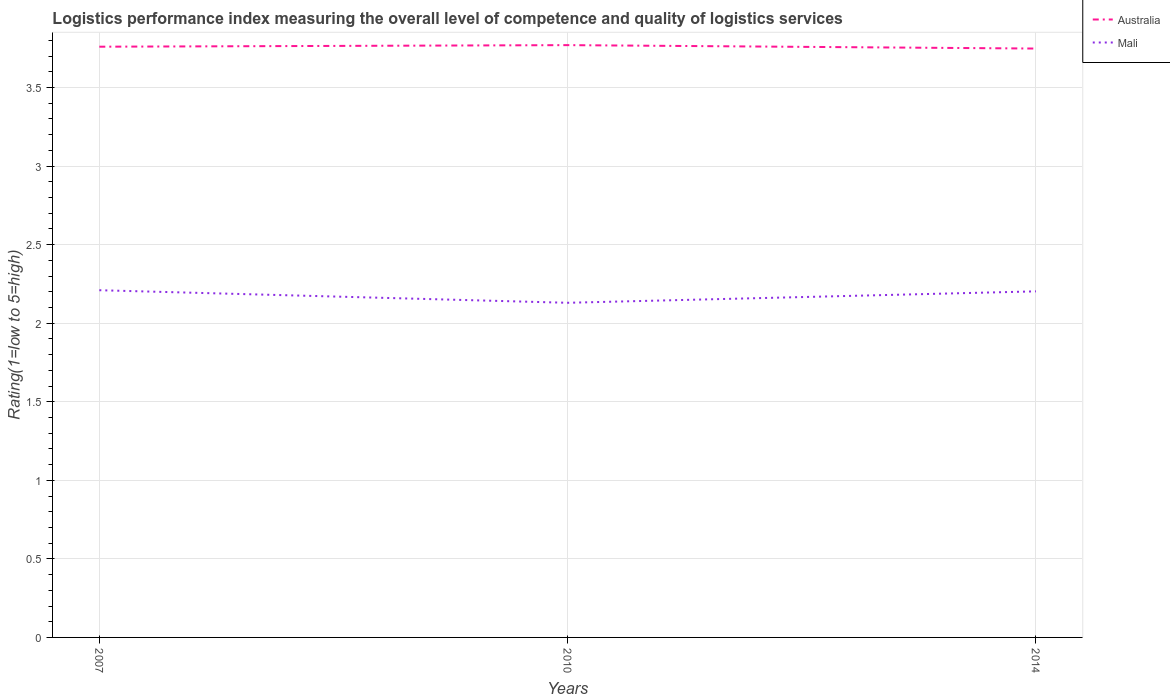How many different coloured lines are there?
Your response must be concise. 2. Does the line corresponding to Mali intersect with the line corresponding to Australia?
Offer a very short reply. No. Across all years, what is the maximum Logistic performance index in Australia?
Provide a succinct answer. 3.75. What is the total Logistic performance index in Mali in the graph?
Give a very brief answer. 0.08. What is the difference between the highest and the second highest Logistic performance index in Australia?
Provide a short and direct response. 0.02. What is the difference between the highest and the lowest Logistic performance index in Mali?
Offer a terse response. 2. Is the Logistic performance index in Mali strictly greater than the Logistic performance index in Australia over the years?
Your answer should be very brief. Yes. How many lines are there?
Your answer should be very brief. 2. What is the difference between two consecutive major ticks on the Y-axis?
Your answer should be compact. 0.5. How are the legend labels stacked?
Keep it short and to the point. Vertical. What is the title of the graph?
Your answer should be compact. Logistics performance index measuring the overall level of competence and quality of logistics services. What is the label or title of the Y-axis?
Provide a succinct answer. Rating(1=low to 5=high). What is the Rating(1=low to 5=high) in Australia in 2007?
Your response must be concise. 3.76. What is the Rating(1=low to 5=high) of Mali in 2007?
Your answer should be compact. 2.21. What is the Rating(1=low to 5=high) of Australia in 2010?
Your answer should be compact. 3.77. What is the Rating(1=low to 5=high) in Mali in 2010?
Offer a terse response. 2.13. What is the Rating(1=low to 5=high) of Australia in 2014?
Provide a succinct answer. 3.75. What is the Rating(1=low to 5=high) in Mali in 2014?
Offer a terse response. 2.2. Across all years, what is the maximum Rating(1=low to 5=high) of Australia?
Offer a terse response. 3.77. Across all years, what is the maximum Rating(1=low to 5=high) in Mali?
Your answer should be very brief. 2.21. Across all years, what is the minimum Rating(1=low to 5=high) of Australia?
Ensure brevity in your answer.  3.75. Across all years, what is the minimum Rating(1=low to 5=high) in Mali?
Provide a short and direct response. 2.13. What is the total Rating(1=low to 5=high) in Australia in the graph?
Give a very brief answer. 11.28. What is the total Rating(1=low to 5=high) in Mali in the graph?
Give a very brief answer. 6.54. What is the difference between the Rating(1=low to 5=high) of Australia in 2007 and that in 2010?
Provide a succinct answer. -0.01. What is the difference between the Rating(1=low to 5=high) of Australia in 2007 and that in 2014?
Ensure brevity in your answer.  0.01. What is the difference between the Rating(1=low to 5=high) in Mali in 2007 and that in 2014?
Offer a terse response. 0.01. What is the difference between the Rating(1=low to 5=high) in Australia in 2010 and that in 2014?
Provide a succinct answer. 0.02. What is the difference between the Rating(1=low to 5=high) of Mali in 2010 and that in 2014?
Provide a succinct answer. -0.07. What is the difference between the Rating(1=low to 5=high) of Australia in 2007 and the Rating(1=low to 5=high) of Mali in 2010?
Your response must be concise. 1.63. What is the difference between the Rating(1=low to 5=high) of Australia in 2007 and the Rating(1=low to 5=high) of Mali in 2014?
Your response must be concise. 1.56. What is the difference between the Rating(1=low to 5=high) in Australia in 2010 and the Rating(1=low to 5=high) in Mali in 2014?
Your answer should be compact. 1.57. What is the average Rating(1=low to 5=high) of Australia per year?
Offer a very short reply. 3.76. What is the average Rating(1=low to 5=high) in Mali per year?
Offer a very short reply. 2.18. In the year 2007, what is the difference between the Rating(1=low to 5=high) of Australia and Rating(1=low to 5=high) of Mali?
Offer a very short reply. 1.55. In the year 2010, what is the difference between the Rating(1=low to 5=high) of Australia and Rating(1=low to 5=high) of Mali?
Give a very brief answer. 1.64. In the year 2014, what is the difference between the Rating(1=low to 5=high) of Australia and Rating(1=low to 5=high) of Mali?
Your response must be concise. 1.55. What is the ratio of the Rating(1=low to 5=high) in Mali in 2007 to that in 2010?
Ensure brevity in your answer.  1.04. What is the ratio of the Rating(1=low to 5=high) of Australia in 2010 to that in 2014?
Offer a very short reply. 1.01. What is the difference between the highest and the second highest Rating(1=low to 5=high) in Australia?
Make the answer very short. 0.01. What is the difference between the highest and the second highest Rating(1=low to 5=high) in Mali?
Provide a succinct answer. 0.01. What is the difference between the highest and the lowest Rating(1=low to 5=high) of Australia?
Make the answer very short. 0.02. 